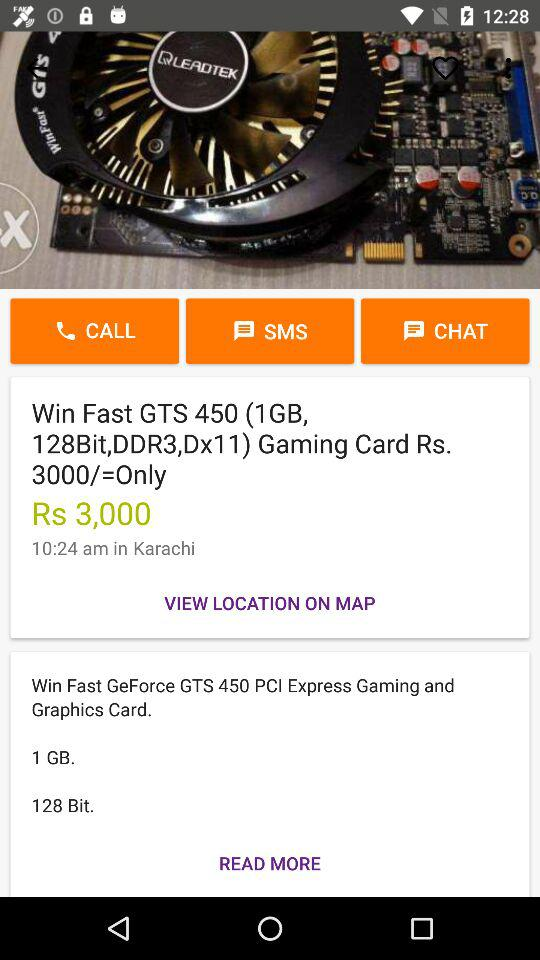What is the price of this graphics card?
Answer the question using a single word or phrase. Rs. 3,000 